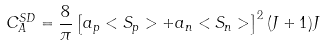<formula> <loc_0><loc_0><loc_500><loc_500>C _ { A } ^ { S D } = \frac { 8 } { \pi } \left [ a _ { p } < S _ { p } > + a _ { n } < S _ { n } > \right ] ^ { 2 } ( J + 1 ) J</formula> 